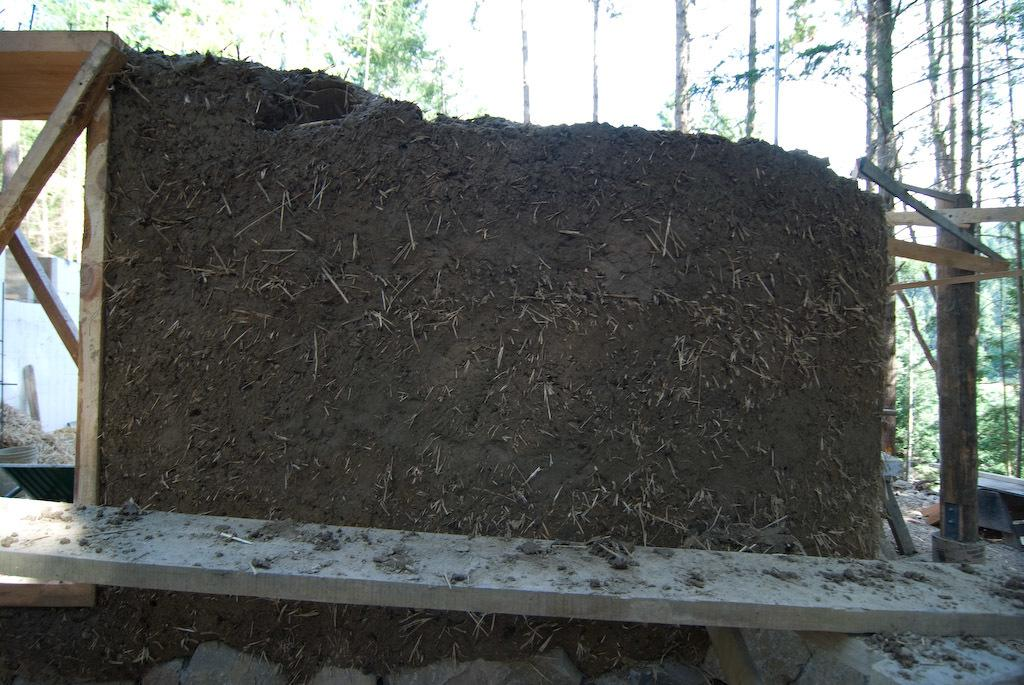What is the main subject of the image? The main subject of the image is a wall with mud. What other objects can be seen in the image? There are wooden planks visible in the image. What can be seen in the background of the image? There are trees in the background of the image. How many letters can be seen scattered on the ground in the image? There are no letters visible on the ground in the image. Can you spot any lizards crawling on the wall with mud in the image? There are no lizards present in the image. 